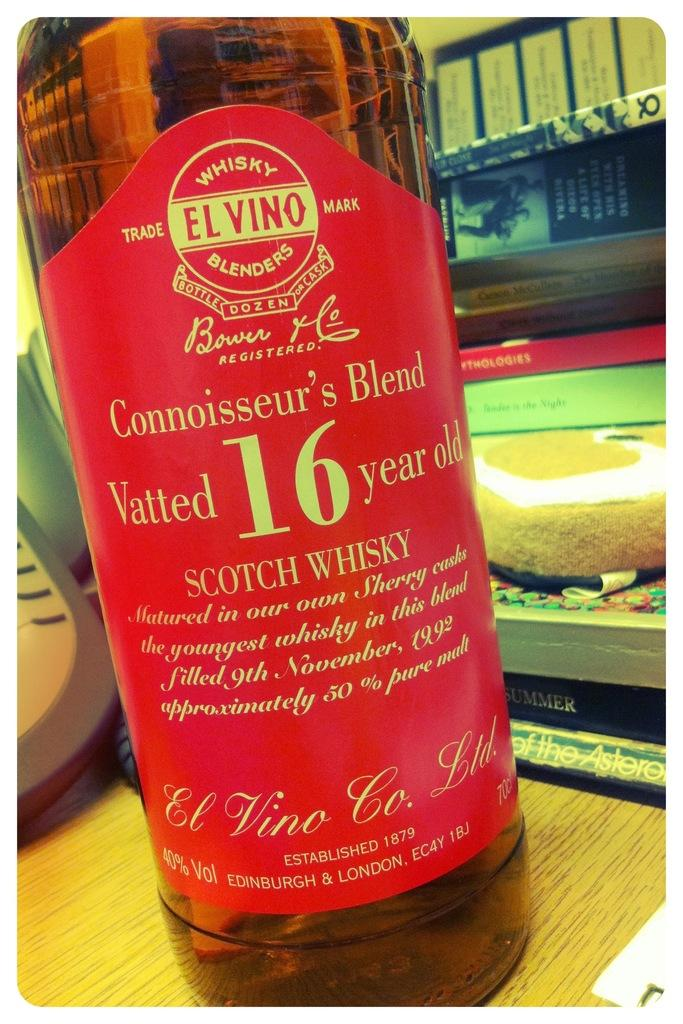<image>
Give a short and clear explanation of the subsequent image. A close up of the red label of a bottle of Elvino 16 year old whisky. 